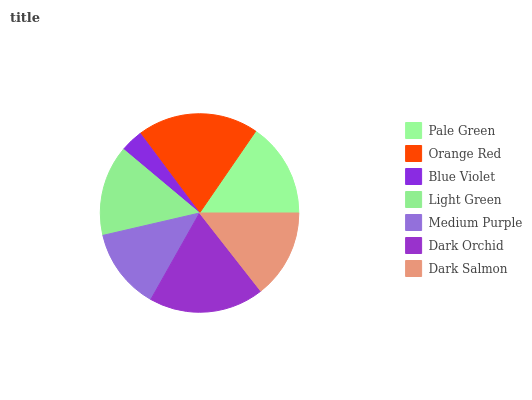Is Blue Violet the minimum?
Answer yes or no. Yes. Is Orange Red the maximum?
Answer yes or no. Yes. Is Orange Red the minimum?
Answer yes or no. No. Is Blue Violet the maximum?
Answer yes or no. No. Is Orange Red greater than Blue Violet?
Answer yes or no. Yes. Is Blue Violet less than Orange Red?
Answer yes or no. Yes. Is Blue Violet greater than Orange Red?
Answer yes or no. No. Is Orange Red less than Blue Violet?
Answer yes or no. No. Is Light Green the high median?
Answer yes or no. Yes. Is Light Green the low median?
Answer yes or no. Yes. Is Pale Green the high median?
Answer yes or no. No. Is Pale Green the low median?
Answer yes or no. No. 